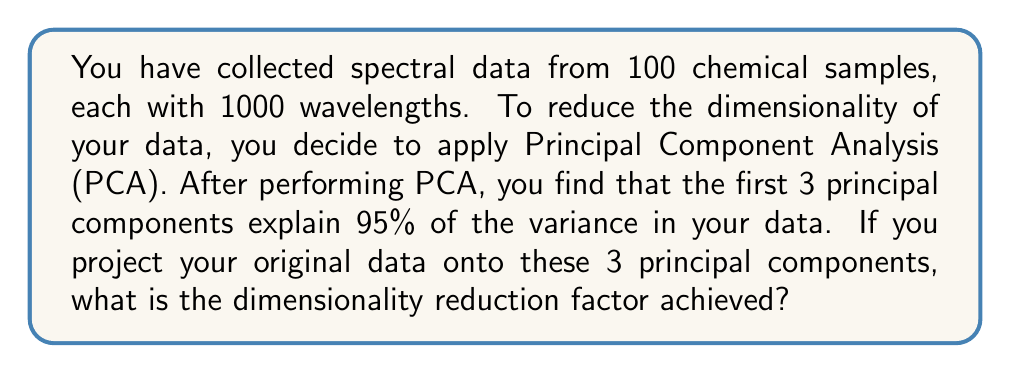Can you answer this question? Let's approach this step-by-step:

1) First, let's understand what we're given:
   - Original data: 100 samples, each with 1000 wavelengths
   - After PCA: 3 principal components explain 95% of the variance

2) The original dimensionality of the data:
   $$\text{Original dimensions} = 1000$$

3) The new dimensionality after projecting onto the first 3 principal components:
   $$\text{New dimensions} = 3$$

4) The dimensionality reduction factor is the ratio of the original dimensions to the new dimensions:

   $$\text{Reduction factor} = \frac{\text{Original dimensions}}{\text{New dimensions}}$$

5) Substituting our values:

   $$\text{Reduction factor} = \frac{1000}{3}$$

6) Simplifying:

   $$\text{Reduction factor} = \frac{1000}{3} \approx 333.33$$

This means the dimensionality has been reduced by a factor of approximately 333.33.

In other words, the new representation of the data uses only about 0.3% (1/333.33) of the original number of dimensions while still capturing 95% of the variance in the data.
Answer: $$\frac{1000}{3} \approx 333.33$$ 